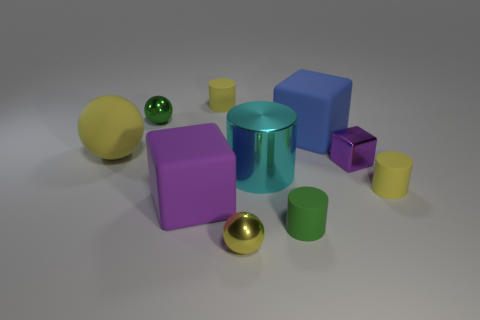Is the number of rubber spheres in front of the small green sphere greater than the number of small blocks that are in front of the tiny cube?
Your answer should be very brief. Yes. Is the color of the big rubber sphere the same as the sphere in front of the purple rubber cube?
Ensure brevity in your answer.  Yes. There is a yellow ball that is the same size as the green ball; what is its material?
Give a very brief answer. Metal. What number of things are either big cylinders or rubber objects that are behind the matte sphere?
Provide a short and direct response. 3. Is the size of the matte sphere the same as the matte cylinder that is on the left side of the green cylinder?
Your answer should be compact. No. How many balls are blue objects or small green objects?
Your answer should be compact. 1. How many tiny yellow cylinders are both in front of the tiny purple shiny thing and behind the green sphere?
Make the answer very short. 0. What number of other objects are there of the same color as the big shiny cylinder?
Ensure brevity in your answer.  0. The green thing that is behind the shiny cube has what shape?
Provide a short and direct response. Sphere. Does the small purple cube have the same material as the big cyan cylinder?
Provide a succinct answer. Yes. 